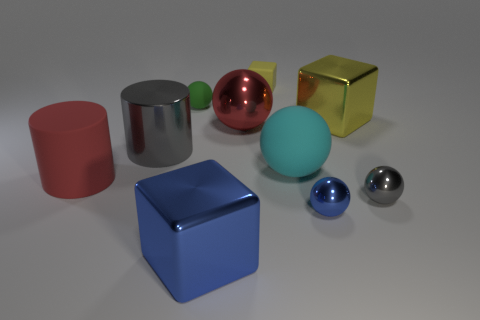Subtract all red shiny balls. How many balls are left? 4 Subtract all yellow spheres. Subtract all purple cylinders. How many spheres are left? 5 Subtract all cylinders. How many objects are left? 8 Subtract 0 blue cylinders. How many objects are left? 10 Subtract all metal balls. Subtract all small purple blocks. How many objects are left? 7 Add 7 red objects. How many red objects are left? 9 Add 6 tiny red matte balls. How many tiny red matte balls exist? 6 